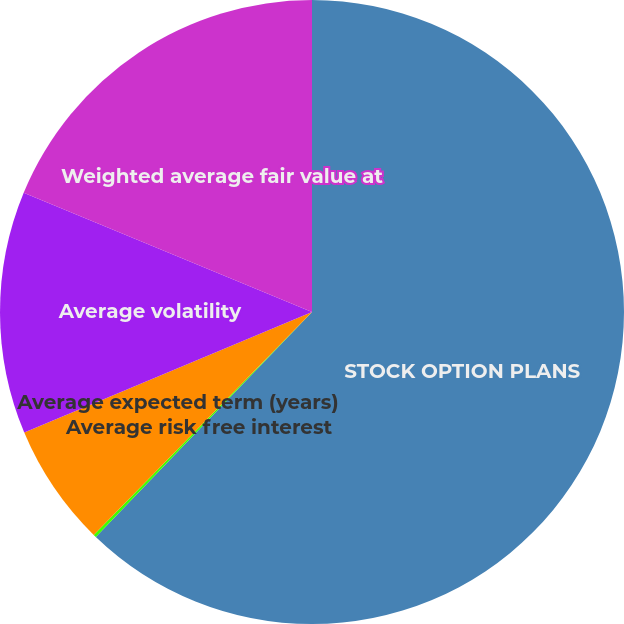Convert chart to OTSL. <chart><loc_0><loc_0><loc_500><loc_500><pie_chart><fcel>STOCK OPTION PLANS<fcel>Average risk free interest<fcel>Average expected term (years)<fcel>Average volatility<fcel>Weighted average fair value at<nl><fcel>62.19%<fcel>0.15%<fcel>6.35%<fcel>12.56%<fcel>18.76%<nl></chart> 